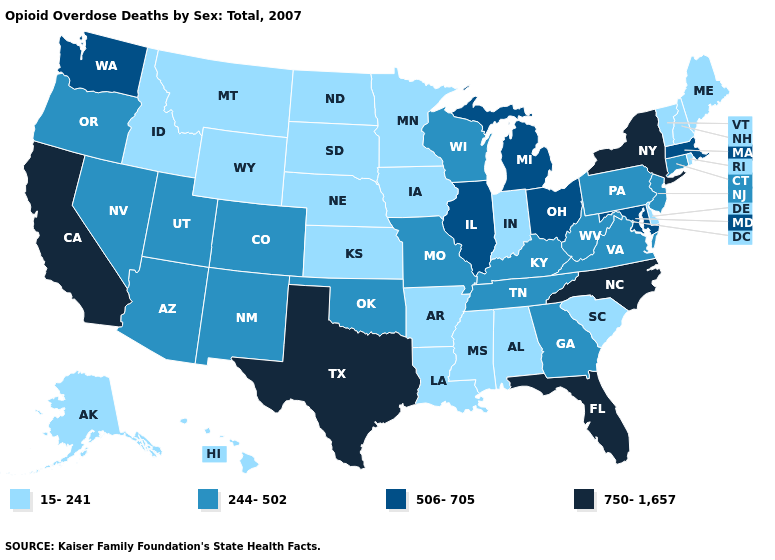Which states hav the highest value in the West?
Write a very short answer. California. Name the states that have a value in the range 750-1,657?
Write a very short answer. California, Florida, New York, North Carolina, Texas. How many symbols are there in the legend?
Write a very short answer. 4. Among the states that border Illinois , which have the lowest value?
Be succinct. Indiana, Iowa. What is the lowest value in states that border Idaho?
Short answer required. 15-241. Name the states that have a value in the range 244-502?
Keep it brief. Arizona, Colorado, Connecticut, Georgia, Kentucky, Missouri, Nevada, New Jersey, New Mexico, Oklahoma, Oregon, Pennsylvania, Tennessee, Utah, Virginia, West Virginia, Wisconsin. Name the states that have a value in the range 244-502?
Concise answer only. Arizona, Colorado, Connecticut, Georgia, Kentucky, Missouri, Nevada, New Jersey, New Mexico, Oklahoma, Oregon, Pennsylvania, Tennessee, Utah, Virginia, West Virginia, Wisconsin. What is the highest value in the USA?
Give a very brief answer. 750-1,657. Which states have the highest value in the USA?
Give a very brief answer. California, Florida, New York, North Carolina, Texas. Name the states that have a value in the range 506-705?
Answer briefly. Illinois, Maryland, Massachusetts, Michigan, Ohio, Washington. What is the value of Nevada?
Keep it brief. 244-502. Does Tennessee have the lowest value in the USA?
Answer briefly. No. Which states have the highest value in the USA?
Write a very short answer. California, Florida, New York, North Carolina, Texas. What is the value of Minnesota?
Write a very short answer. 15-241. 